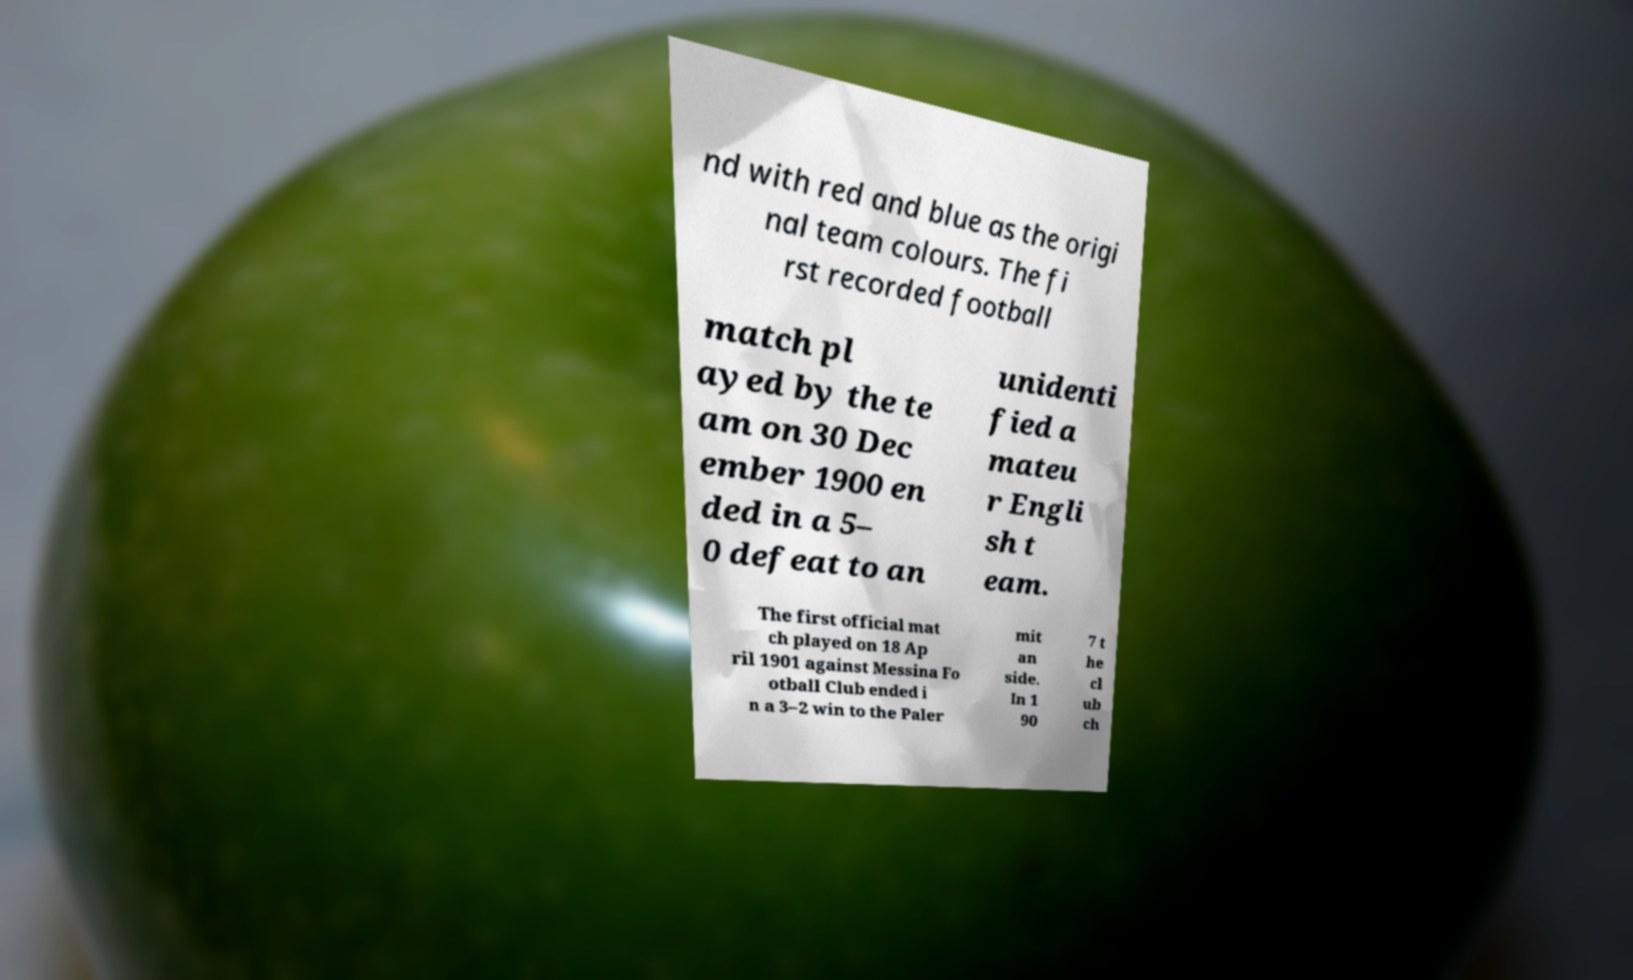Could you assist in decoding the text presented in this image and type it out clearly? nd with red and blue as the origi nal team colours. The fi rst recorded football match pl ayed by the te am on 30 Dec ember 1900 en ded in a 5– 0 defeat to an unidenti fied a mateu r Engli sh t eam. The first official mat ch played on 18 Ap ril 1901 against Messina Fo otball Club ended i n a 3–2 win to the Paler mit an side. In 1 90 7 t he cl ub ch 